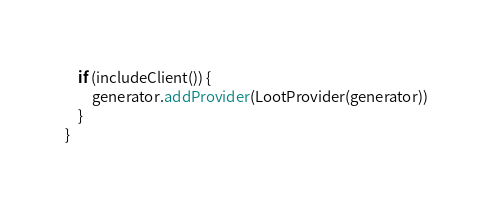Convert code to text. <code><loc_0><loc_0><loc_500><loc_500><_Kotlin_>	if (includeClient()) {
		generator.addProvider(LootProvider(generator))
	}
}</code> 